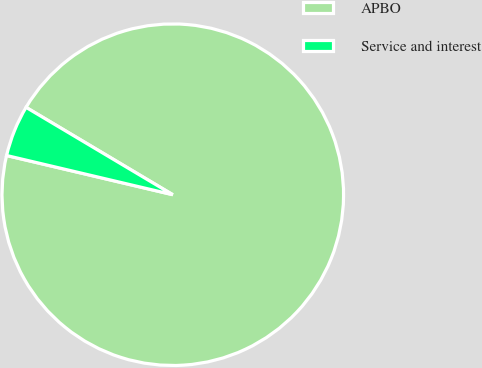Convert chart to OTSL. <chart><loc_0><loc_0><loc_500><loc_500><pie_chart><fcel>APBO<fcel>Service and interest<nl><fcel>95.14%<fcel>4.86%<nl></chart> 